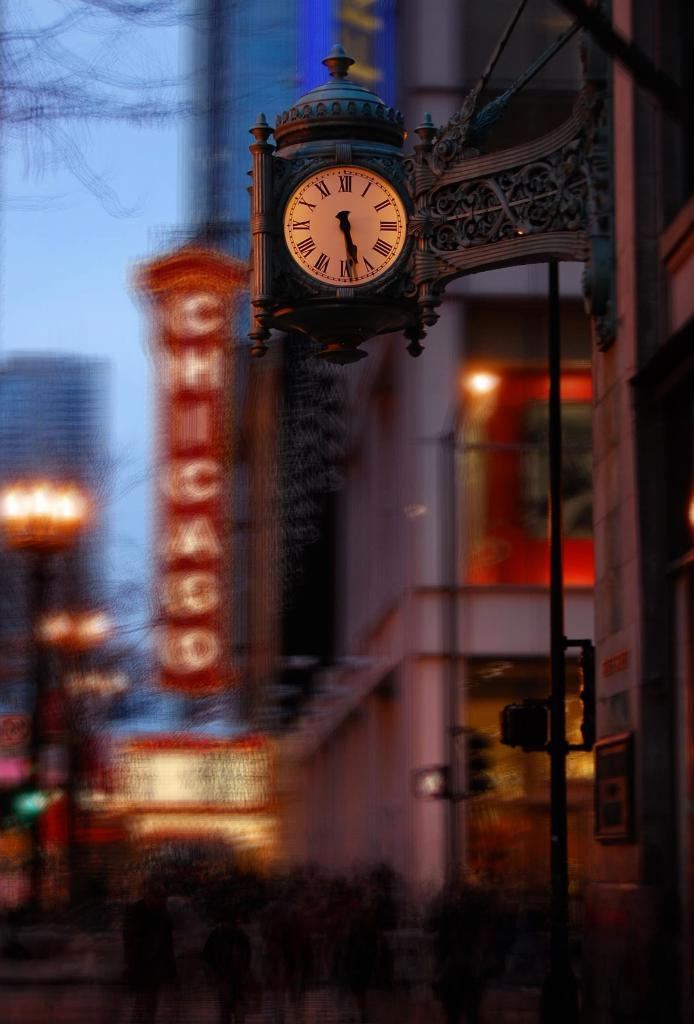<image>
Create a compact narrative representing the image presented. A Roman numeral clock in front of a Chicago Theater sign reads 5:28. 